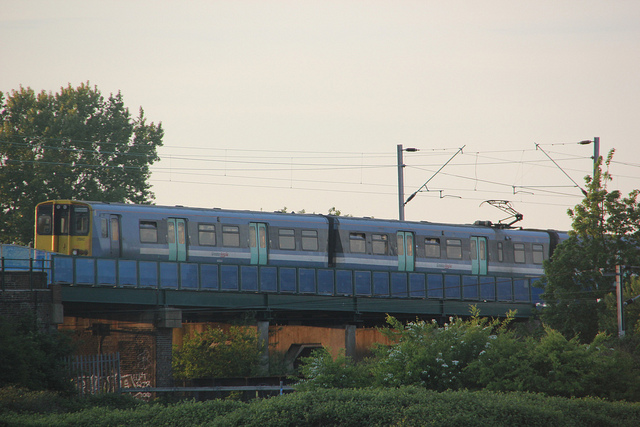<image>What is constructed under the bridge? I don't know what is constructed under the bridge. It can be a wall, tent, subway, poles, garden, tunnel, or fence. What is written on the train cars? It is unknown what is written on the train cars. It appears that there is no writing visible. What color is the M on the graffiti? It is ambiguous what color the M on the graffiti is. It could be blue, white, red, brown, or white outline and yellow. What is constructed under the bridge? I don't know what is constructed under the bridge. It can be a wall, tent, subway, poles, garden, tunnel or fence. What is written on the train cars? I don't know what is written on the train cars. It seems like there is nothing written or the writing is not visible. However, it can also be numbers. What color is the M on the graffiti? It is unanswerable what color is the M on the graffiti. 